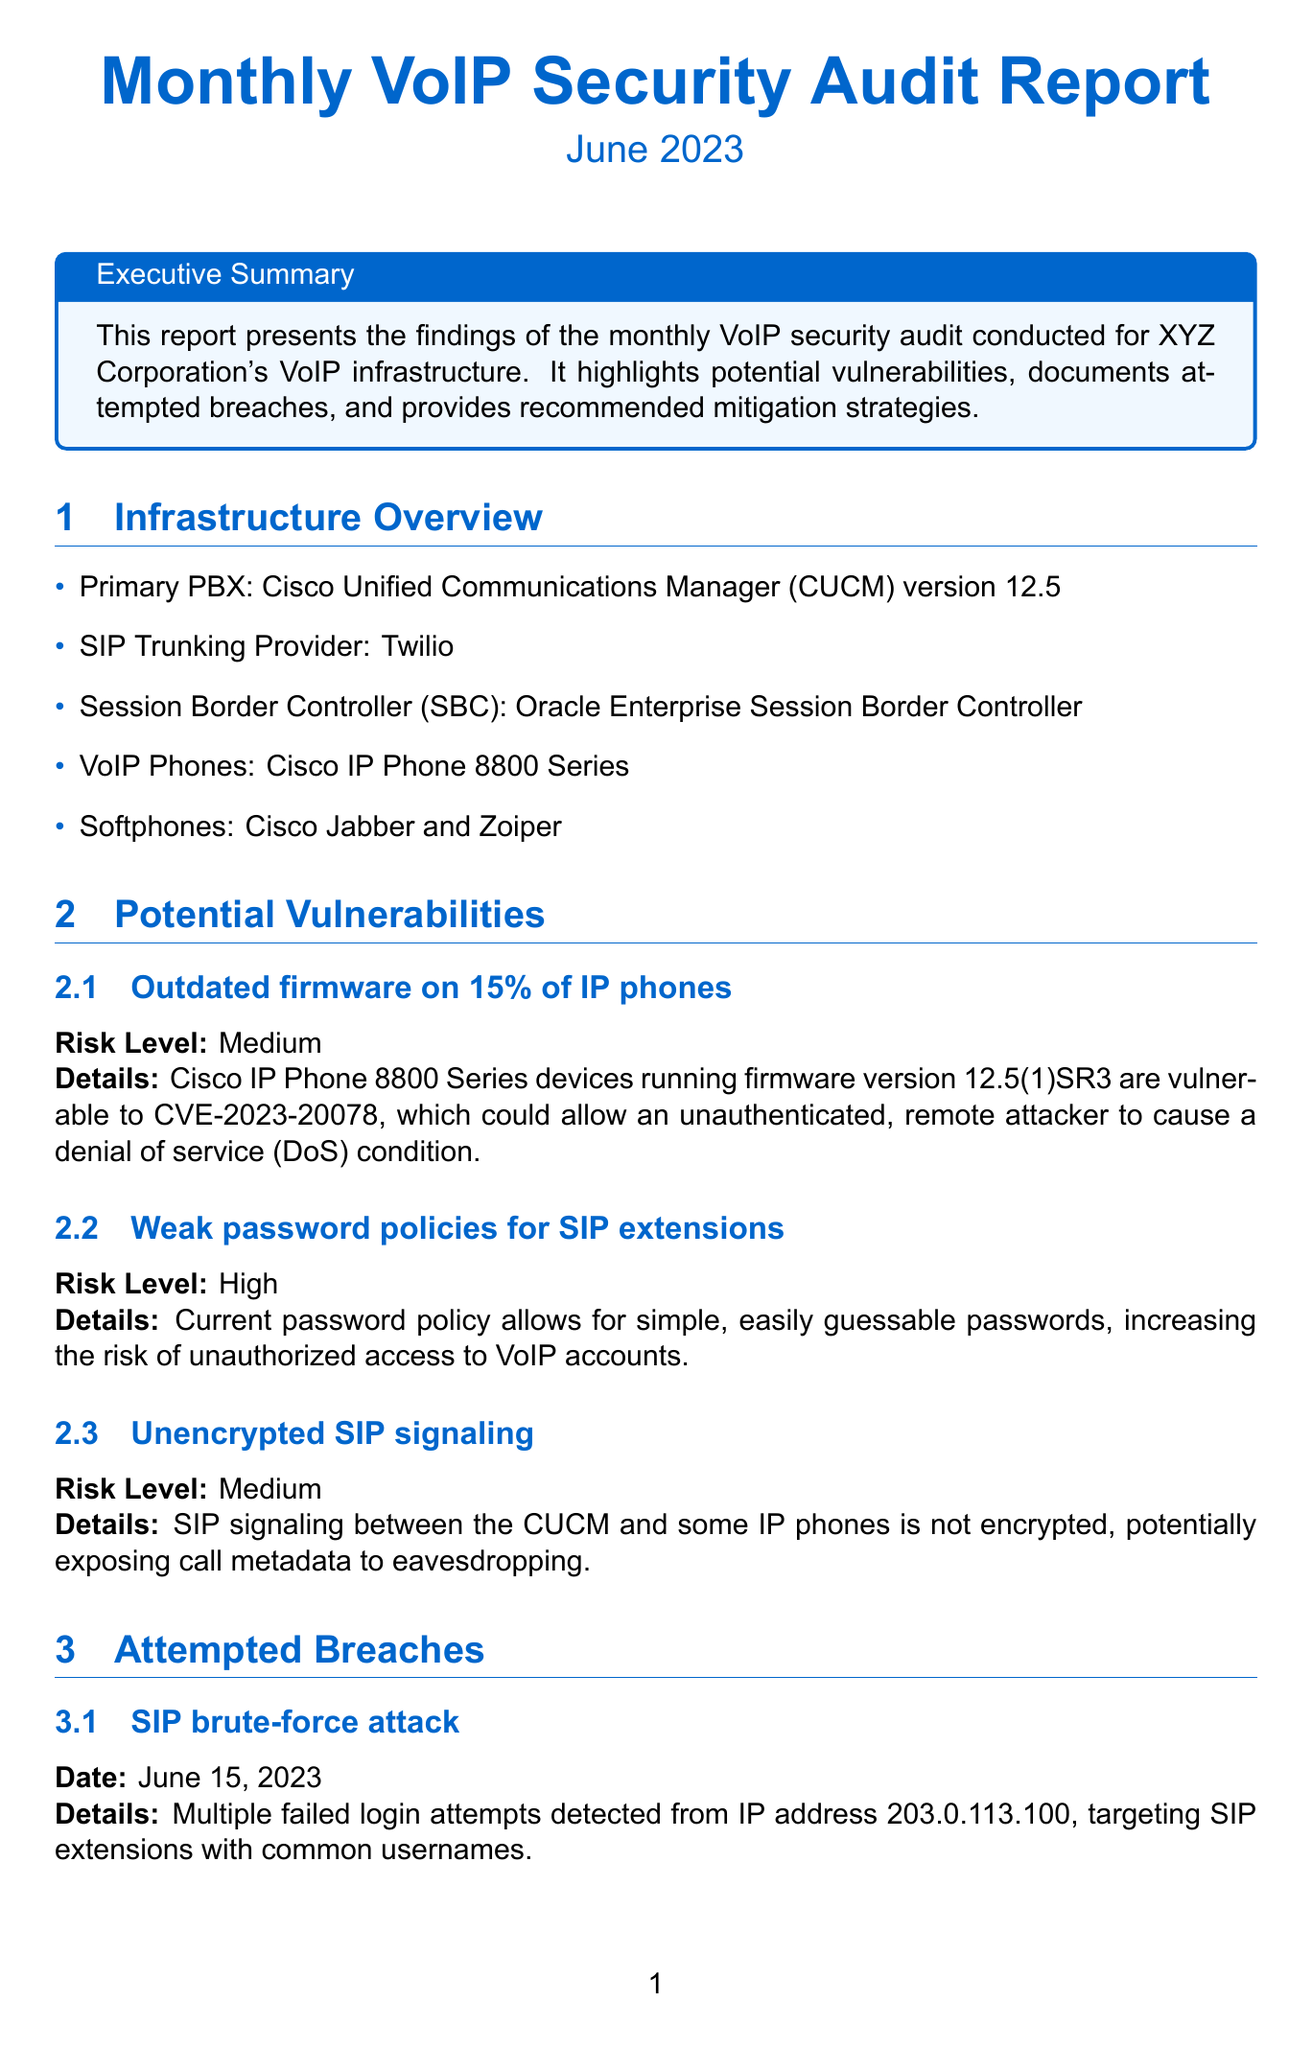What is the title of the report? The title of the report is stated at the beginning of the document.
Answer: Monthly VoIP Security Audit Report - June 2023 What percentage of IP phones have outdated firmware? The report mentions this percentage in the section about potential vulnerabilities.
Answer: 15% What is the risk level associated with weak password policies for SIP extensions? The risk level is provided in the section addressing vulnerabilities.
Answer: High When was the SIP brute-force attack attempted? The date of the incident is mentioned in the section detailing attempted breaches.
Answer: June 15, 2023 What is one recommended mitigation strategy for outdated IP phone firmware? The recommendations include specific actions to address vulnerabilities, such as this one.
Answer: Update IP phone firmware What compliance status is indicated for PCI DSS? The compliance status is summarized in the compliance section of the report.
Answer: Compliant with requirements 3.4 and 4.1 Which VoIP phone models are mentioned in the infrastructure overview? The overview specifies the models in use, which is relevant information to retrieve.
Answer: Cisco IP Phone 8800 Series What should be configured to enforce complex passwords? The document specifies actions to implement stronger security measures in the recommendations.
Answer: CUCM What is the priority assigned to enabling TLS for SIP signaling? The priorities for the recommended strategies are listed in the corresponding section.
Answer: Medium 